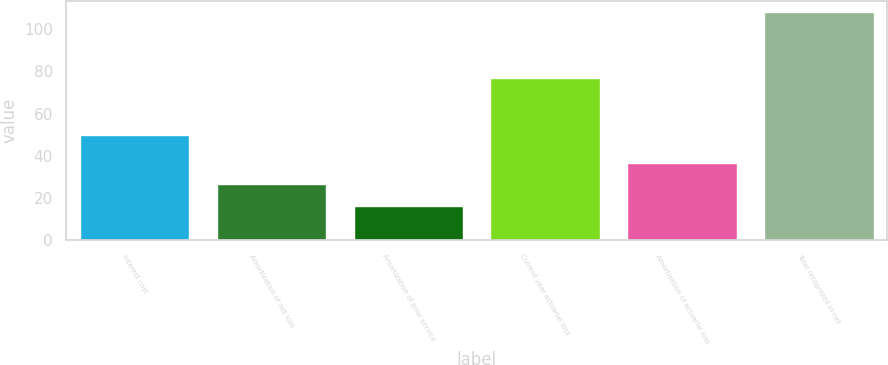<chart> <loc_0><loc_0><loc_500><loc_500><bar_chart><fcel>Interest cost<fcel>Amortization of net loss<fcel>Amortization of prior service<fcel>Current year actuarial loss<fcel>Amortization of actuarial loss<fcel>Total recognized in net<nl><fcel>50<fcel>26.4<fcel>16.2<fcel>77<fcel>36.6<fcel>108<nl></chart> 